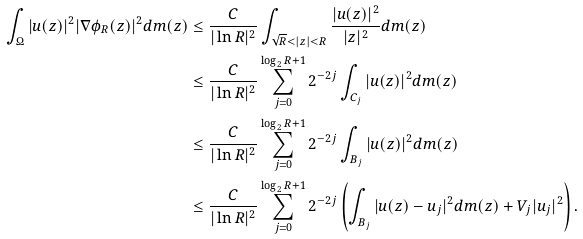<formula> <loc_0><loc_0><loc_500><loc_500>\int _ { \Omega } | u ( z ) | ^ { 2 } | \nabla \phi _ { R } ( z ) | ^ { 2 } d m ( z ) & \leq \frac { C } { | \ln R | ^ { 2 } } \int _ { \sqrt { R } < | z | < R } \frac { | u ( z ) | ^ { 2 } } { | z | ^ { 2 } } d m ( z ) \\ & \leq \frac { C } { | \ln R | ^ { 2 } } \sum _ { j = 0 } ^ { \log _ { 2 } R + 1 } 2 ^ { - 2 j } \int _ { C _ { j } } | u ( z ) | ^ { 2 } d m ( z ) \\ & \leq \frac { C } { | \ln R | ^ { 2 } } \sum _ { j = 0 } ^ { \log _ { 2 } R + 1 } 2 ^ { - 2 j } \int _ { B _ { j } } | u ( z ) | ^ { 2 } d m ( z ) \\ & \leq \frac { C } { | \ln R | ^ { 2 } } \sum _ { j = 0 } ^ { \log _ { 2 } R + 1 } 2 ^ { - 2 j } \left ( \int _ { B _ { j } } | u ( z ) - u _ { j } | ^ { 2 } d m ( z ) + V _ { j } | u _ { j } | ^ { 2 } \right ) . \\</formula> 